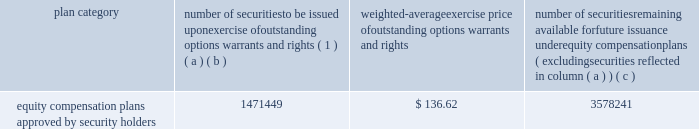Part a0iii item a010 .
Directors , executive officers and corporate governance for the information required by this item a010 with respect to our executive officers , see part a0i , item 1 .
Of this report .
For the other information required by this item a010 , see 201celection of directors , 201d 201cnominees for election to the board of directors , 201d 201ccorporate governance 201d and 201csection a016 ( a ) beneficial ownership reporting compliance , 201d in the proxy statement for our 2019 annual meeting , which information is incorporated herein by reference .
The proxy statement for our 2019 annual meeting will be filed within 120 a0days after the end of the fiscal year covered by this annual report on form 10-k .
Item a011 .
Executive compensation for the information required by this item a011 , see 201ccompensation discussion and analysis , 201d 201ccompensation committee report , 201d and 201cexecutive compensation 201d in the proxy statement for our 2019 annual meeting , which information is incorporated herein by reference .
Item a012 .
Security ownership of certain beneficial owners and management and related stockholder matters for the information required by this item a012 with respect to beneficial ownership of our common stock , see 201csecurity ownership of certain beneficial owners and management 201d in the proxy statement for our 2019 annual meeting , which information is incorporated herein by reference .
The table sets forth certain information as of december a031 , 2018 regarding our equity plans : plan category number of securities to be issued upon exercise of outstanding options , warrants and rights ( 1 ) weighted-average exercise price of outstanding options , warrants and rights number of securities remaining available for future issuance under equity compensation plans ( excluding securities reflected in column ( a ) ( b ) ( c ) equity compensation plans approved by security holders 1471449 $ 136.62 3578241 ( 1 ) the number of securities in column ( a ) include 22290 shares of common stock underlying performance stock units if maximum performance levels are achieved ; the actual number of shares , if any , to be issued with respect to the performance stock units will be based on performance with respect to specified financial and relative stock price measures .
Item a013 .
Certain relationships and related transactions , and director independence for the information required by this item a013 , see 201ccertain transactions 201d and 201ccorporate governance 201d in the proxy statement for our 2019 annual meeting , which information is incorporated herein by reference .
Item a014 .
Principal accounting fees and services for the information required by this item a014 , see 201caudit and non-audit fees 201d and 201caudit committee pre-approval procedures 201d in the proxy statement for our 2019 annual meeting , which information is incorporated herein by reference. .
Part a0iii item a010 .
Directors , executive officers and corporate governance for the information required by this item a010 with respect to our executive officers , see part a0i , item 1 .
Of this report .
For the other information required by this item a010 , see 201celection of directors , 201d 201cnominees for election to the board of directors , 201d 201ccorporate governance 201d and 201csection a016 ( a ) beneficial ownership reporting compliance , 201d in the proxy statement for our 2019 annual meeting , which information is incorporated herein by reference .
The proxy statement for our 2019 annual meeting will be filed within 120 a0days after the end of the fiscal year covered by this annual report on form 10-k .
Item a011 .
Executive compensation for the information required by this item a011 , see 201ccompensation discussion and analysis , 201d 201ccompensation committee report , 201d and 201cexecutive compensation 201d in the proxy statement for our 2019 annual meeting , which information is incorporated herein by reference .
Item a012 .
Security ownership of certain beneficial owners and management and related stockholder matters for the information required by this item a012 with respect to beneficial ownership of our common stock , see 201csecurity ownership of certain beneficial owners and management 201d in the proxy statement for our 2019 annual meeting , which information is incorporated herein by reference .
The following table sets forth certain information as of december a031 , 2018 regarding our equity plans : plan category number of securities to be issued upon exercise of outstanding options , warrants and rights ( 1 ) weighted-average exercise price of outstanding options , warrants and rights number of securities remaining available for future issuance under equity compensation plans ( excluding securities reflected in column ( a ) ( b ) ( c ) equity compensation plans approved by security holders 1471449 $ 136.62 3578241 ( 1 ) the number of securities in column ( a ) include 22290 shares of common stock underlying performance stock units if maximum performance levels are achieved ; the actual number of shares , if any , to be issued with respect to the performance stock units will be based on performance with respect to specified financial and relative stock price measures .
Item a013 .
Certain relationships and related transactions , and director independence for the information required by this item a013 , see 201ccertain transactions 201d and 201ccorporate governance 201d in the proxy statement for our 2019 annual meeting , which information is incorporated herein by reference .
Item a014 .
Principal accounting fees and services for the information required by this item a014 , see 201caudit and non-audit fees 201d and 201caudit committee pre-approval procedures 201d in the proxy statement for our 2019 annual meeting , which information is incorporated herein by reference. .
What portion of the securities approved by the security holders is issued? 
Computations: (1471449 / (1471449 + 3578241))
Answer: 0.29139. Part a0iii item a010 .
Directors , executive officers and corporate governance for the information required by this item a010 with respect to our executive officers , see part a0i , item 1 .
Of this report .
For the other information required by this item a010 , see 201celection of directors , 201d 201cnominees for election to the board of directors , 201d 201ccorporate governance 201d and 201csection a016 ( a ) beneficial ownership reporting compliance , 201d in the proxy statement for our 2019 annual meeting , which information is incorporated herein by reference .
The proxy statement for our 2019 annual meeting will be filed within 120 a0days after the end of the fiscal year covered by this annual report on form 10-k .
Item a011 .
Executive compensation for the information required by this item a011 , see 201ccompensation discussion and analysis , 201d 201ccompensation committee report , 201d and 201cexecutive compensation 201d in the proxy statement for our 2019 annual meeting , which information is incorporated herein by reference .
Item a012 .
Security ownership of certain beneficial owners and management and related stockholder matters for the information required by this item a012 with respect to beneficial ownership of our common stock , see 201csecurity ownership of certain beneficial owners and management 201d in the proxy statement for our 2019 annual meeting , which information is incorporated herein by reference .
The table sets forth certain information as of december a031 , 2018 regarding our equity plans : plan category number of securities to be issued upon exercise of outstanding options , warrants and rights ( 1 ) weighted-average exercise price of outstanding options , warrants and rights number of securities remaining available for future issuance under equity compensation plans ( excluding securities reflected in column ( a ) ( b ) ( c ) equity compensation plans approved by security holders 1471449 $ 136.62 3578241 ( 1 ) the number of securities in column ( a ) include 22290 shares of common stock underlying performance stock units if maximum performance levels are achieved ; the actual number of shares , if any , to be issued with respect to the performance stock units will be based on performance with respect to specified financial and relative stock price measures .
Item a013 .
Certain relationships and related transactions , and director independence for the information required by this item a013 , see 201ccertain transactions 201d and 201ccorporate governance 201d in the proxy statement for our 2019 annual meeting , which information is incorporated herein by reference .
Item a014 .
Principal accounting fees and services for the information required by this item a014 , see 201caudit and non-audit fees 201d and 201caudit committee pre-approval procedures 201d in the proxy statement for our 2019 annual meeting , which information is incorporated herein by reference. .
Part a0iii item a010 .
Directors , executive officers and corporate governance for the information required by this item a010 with respect to our executive officers , see part a0i , item 1 .
Of this report .
For the other information required by this item a010 , see 201celection of directors , 201d 201cnominees for election to the board of directors , 201d 201ccorporate governance 201d and 201csection a016 ( a ) beneficial ownership reporting compliance , 201d in the proxy statement for our 2019 annual meeting , which information is incorporated herein by reference .
The proxy statement for our 2019 annual meeting will be filed within 120 a0days after the end of the fiscal year covered by this annual report on form 10-k .
Item a011 .
Executive compensation for the information required by this item a011 , see 201ccompensation discussion and analysis , 201d 201ccompensation committee report , 201d and 201cexecutive compensation 201d in the proxy statement for our 2019 annual meeting , which information is incorporated herein by reference .
Item a012 .
Security ownership of certain beneficial owners and management and related stockholder matters for the information required by this item a012 with respect to beneficial ownership of our common stock , see 201csecurity ownership of certain beneficial owners and management 201d in the proxy statement for our 2019 annual meeting , which information is incorporated herein by reference .
The following table sets forth certain information as of december a031 , 2018 regarding our equity plans : plan category number of securities to be issued upon exercise of outstanding options , warrants and rights ( 1 ) weighted-average exercise price of outstanding options , warrants and rights number of securities remaining available for future issuance under equity compensation plans ( excluding securities reflected in column ( a ) ( b ) ( c ) equity compensation plans approved by security holders 1471449 $ 136.62 3578241 ( 1 ) the number of securities in column ( a ) include 22290 shares of common stock underlying performance stock units if maximum performance levels are achieved ; the actual number of shares , if any , to be issued with respect to the performance stock units will be based on performance with respect to specified financial and relative stock price measures .
Item a013 .
Certain relationships and related transactions , and director independence for the information required by this item a013 , see 201ccertain transactions 201d and 201ccorporate governance 201d in the proxy statement for our 2019 annual meeting , which information is incorporated herein by reference .
Item a014 .
Principal accounting fees and services for the information required by this item a014 , see 201caudit and non-audit fees 201d and 201caudit committee pre-approval procedures 201d in the proxy statement for our 2019 annual meeting , which information is incorporated herein by reference. .
What is the ratio of securities remaining to securities issued? 
Computations: (3578241 / 1471449)
Answer: 2.43178. 